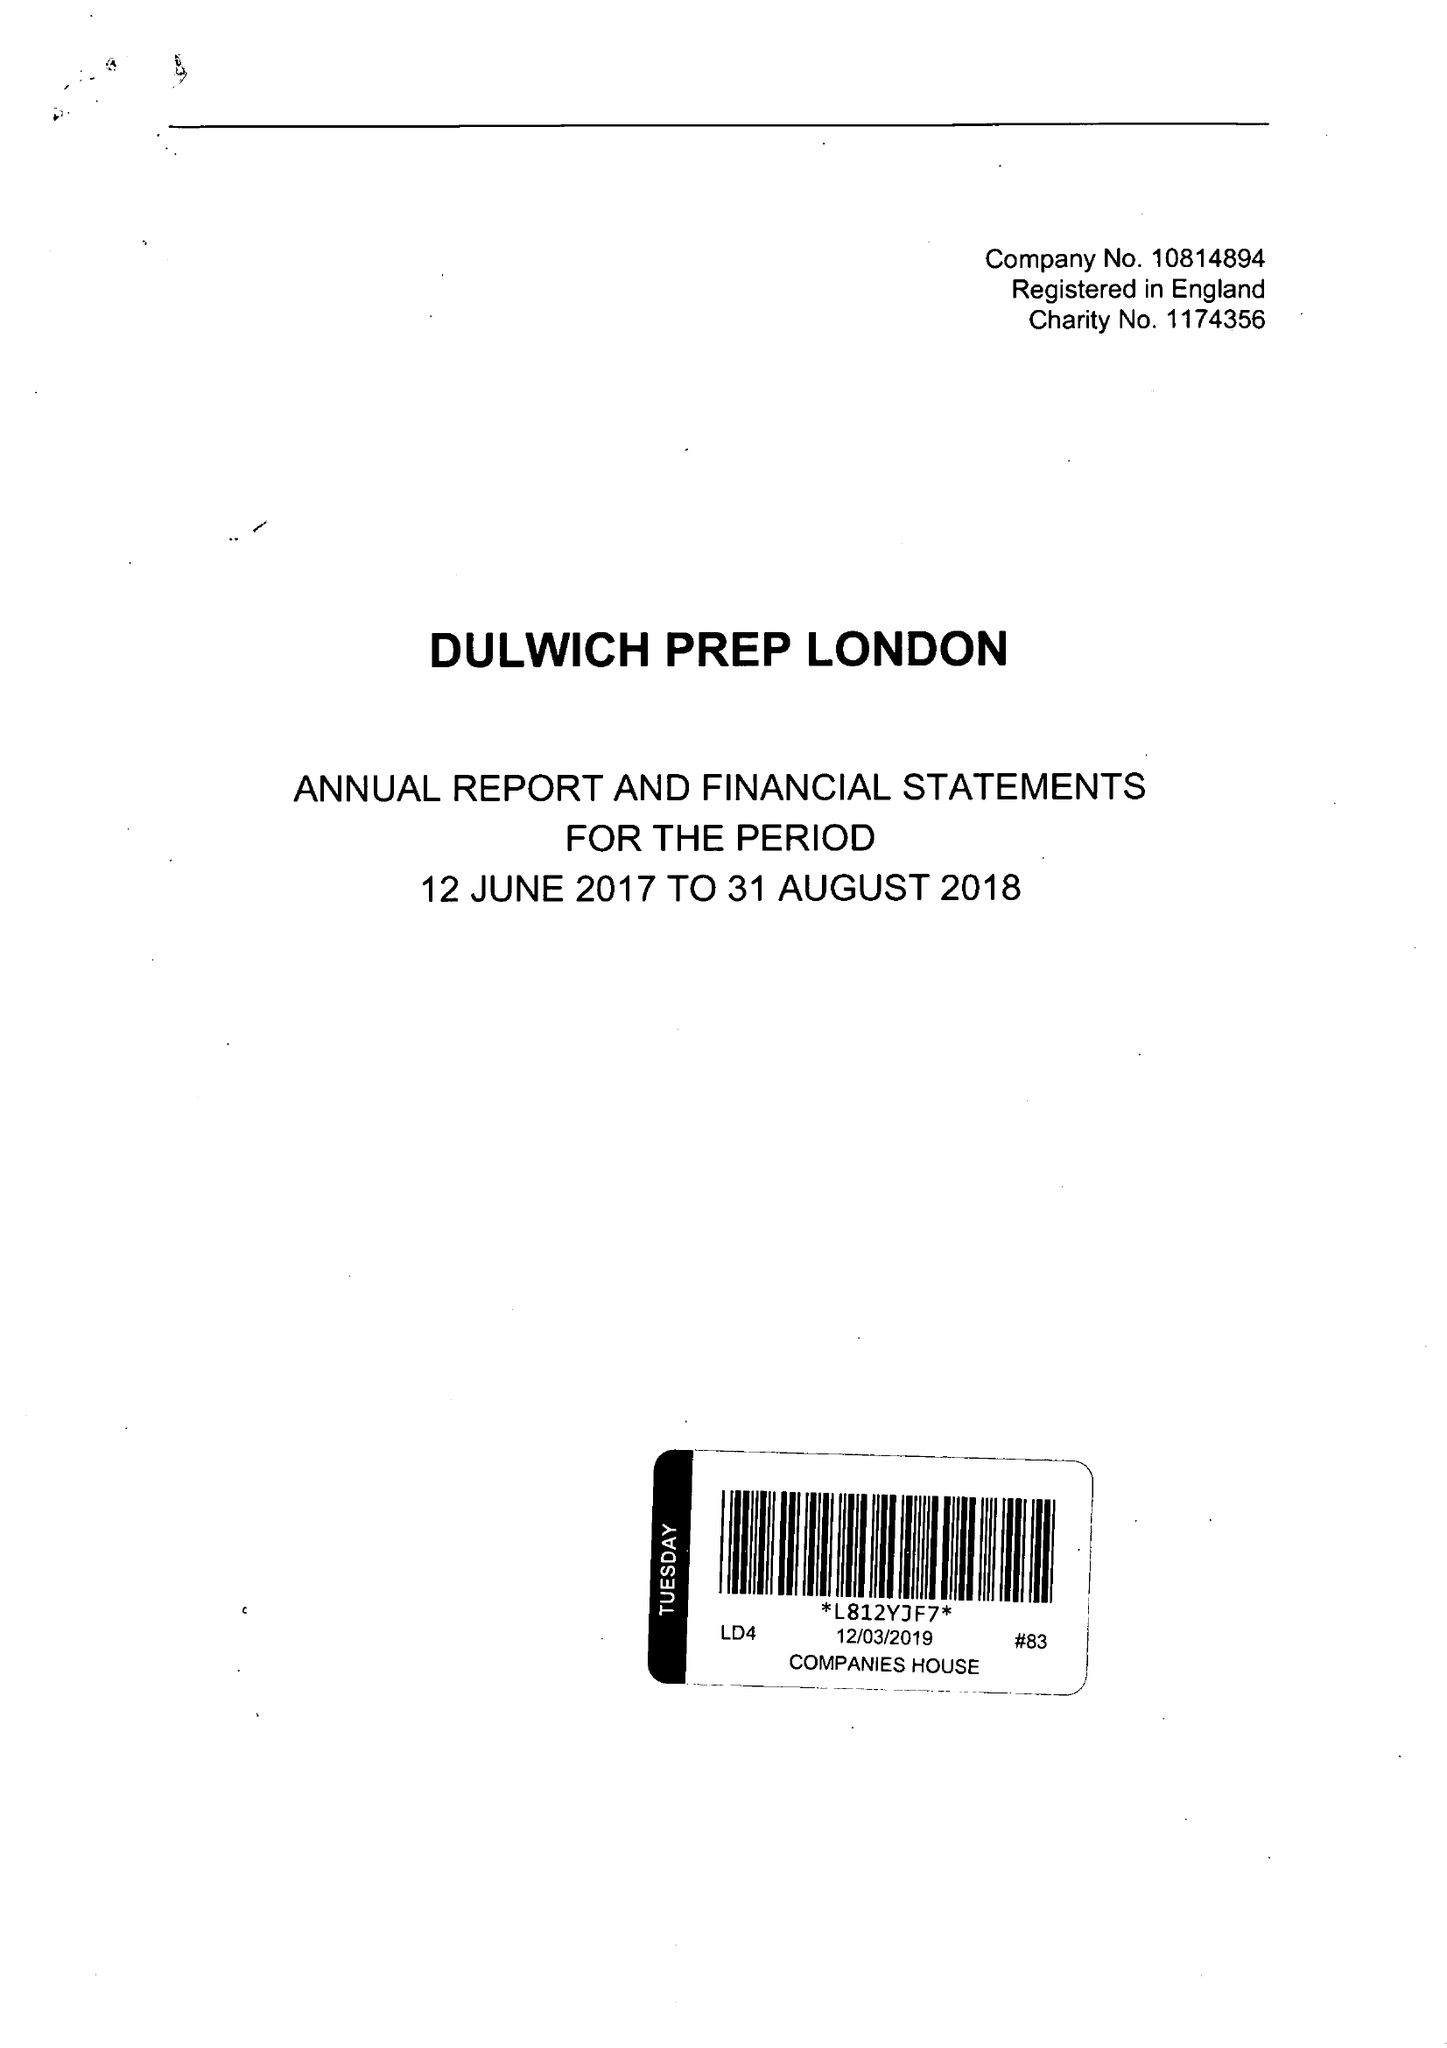What is the value for the address__post_town?
Answer the question using a single word or phrase. LONDON 